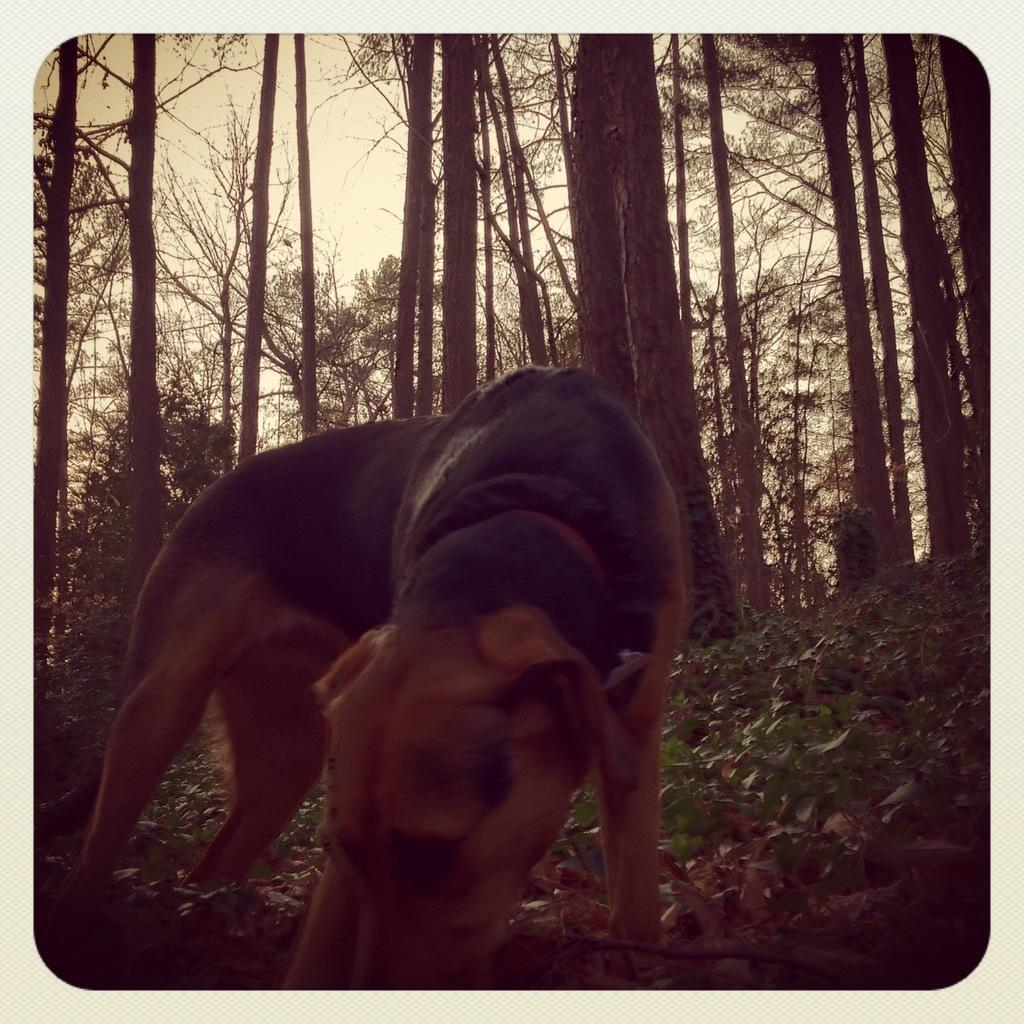What animal is standing on the ground in the image? There is a dog standing on the ground in the image. What type of vegetation is visible behind the dog? There are trees visible behind the dog. What type of ground surface is the dog standing on? There is grass on the ground. What is visible at the top of the image? The sky is visible at the top of the image. What type of ornament is hanging from the dog's collar in the image? There is no ornament hanging from the dog's collar in the image; the dog is not wearing a collar. What type of stone can be seen in the image? There is no stone present in the image. 